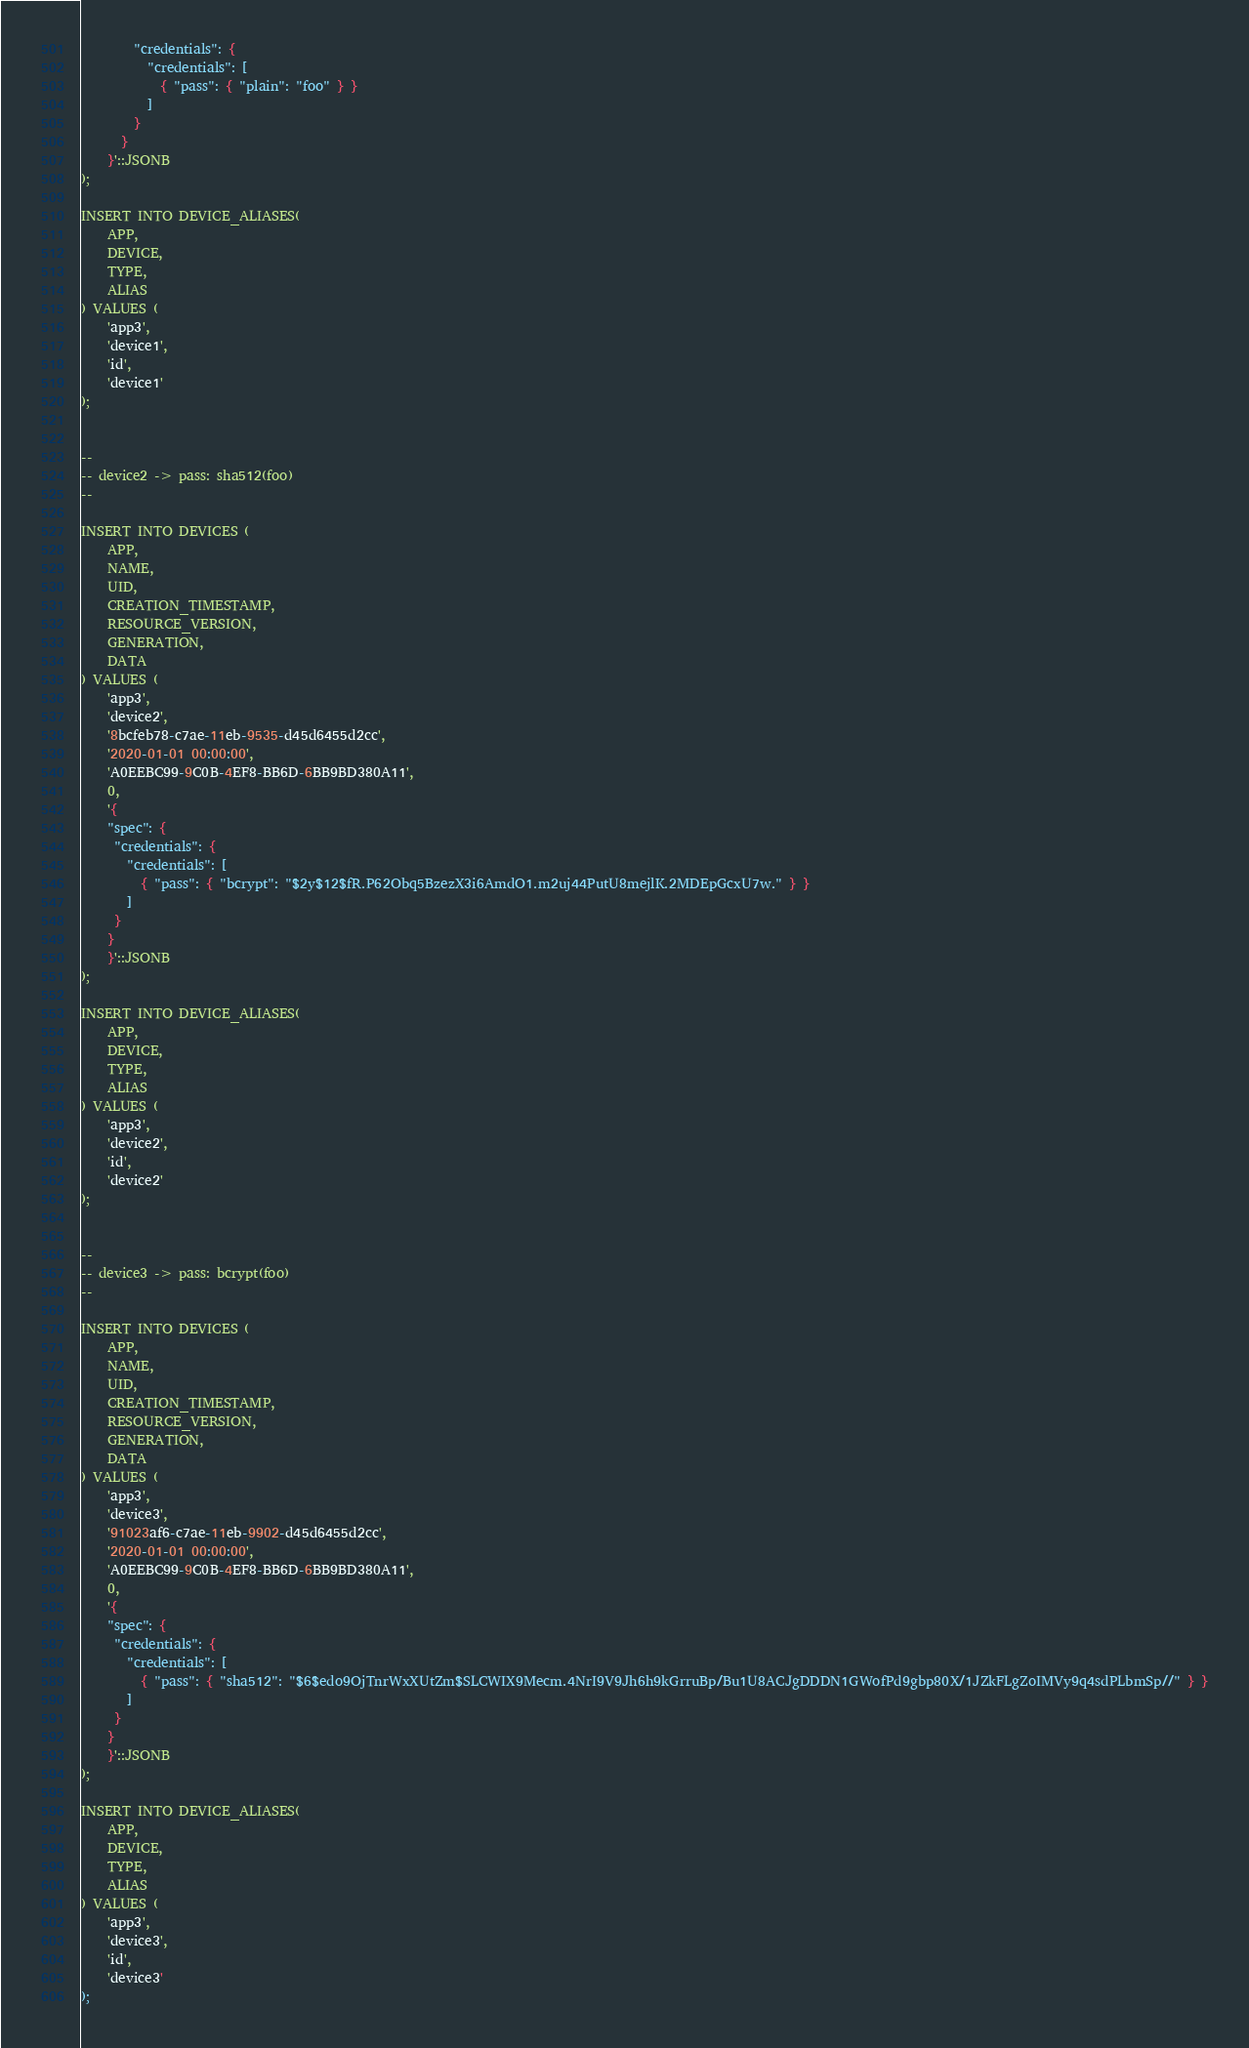Convert code to text. <code><loc_0><loc_0><loc_500><loc_500><_SQL_>        "credentials": {
          "credentials": [
            { "pass": { "plain": "foo" } }
          ]
        }
      }
    }'::JSONB
);

INSERT INTO DEVICE_ALIASES(
    APP,
    DEVICE,
    TYPE,
    ALIAS
) VALUES (
    'app3',
    'device1',
    'id',
    'device1'
);


--
-- device2 -> pass: sha512(foo)
--

INSERT INTO DEVICES (
    APP,
    NAME,
    UID,
    CREATION_TIMESTAMP,
    RESOURCE_VERSION,
    GENERATION,
    DATA
) VALUES (
    'app3',
    'device2',
    '8bcfeb78-c7ae-11eb-9535-d45d6455d2cc',
    '2020-01-01 00:00:00',
    'A0EEBC99-9C0B-4EF8-BB6D-6BB9BD380A11',
    0,
    '{
    "spec": {
     "credentials": {
       "credentials": [
         { "pass": { "bcrypt": "$2y$12$fR.P62Obq5BzezX3i6AmdO1.m2uj44PutU8mejlK.2MDEpGcxU7w." } }
       ]
     }
    }
    }'::JSONB
);

INSERT INTO DEVICE_ALIASES(
    APP,
    DEVICE,
    TYPE,
    ALIAS
) VALUES (
    'app3',
    'device2',
    'id',
    'device2'
);


--
-- device3 -> pass: bcrypt(foo)
--

INSERT INTO DEVICES (
    APP,
    NAME,
    UID,
    CREATION_TIMESTAMP,
    RESOURCE_VERSION,
    GENERATION,
    DATA
) VALUES (
    'app3',
    'device3',
    '91023af6-c7ae-11eb-9902-d45d6455d2cc',
    '2020-01-01 00:00:00',
    'A0EEBC99-9C0B-4EF8-BB6D-6BB9BD380A11',
    0,
    '{
    "spec": {
     "credentials": {
       "credentials": [
         { "pass": { "sha512": "$6$edo9OjTnrWxXUtZm$SLCWIX9Mecm.4NrI9V9Jh6h9kGrruBp/Bu1U8ACJgDDDN1GWofPd9gbp80X/1JZkFLgZoIMVy9q4sdPLbmSp//" } }
       ]
     }
    }
    }'::JSONB
);

INSERT INTO DEVICE_ALIASES(
    APP,
    DEVICE,
    TYPE,
    ALIAS
) VALUES (
    'app3',
    'device3',
    'id',
    'device3'
);</code> 